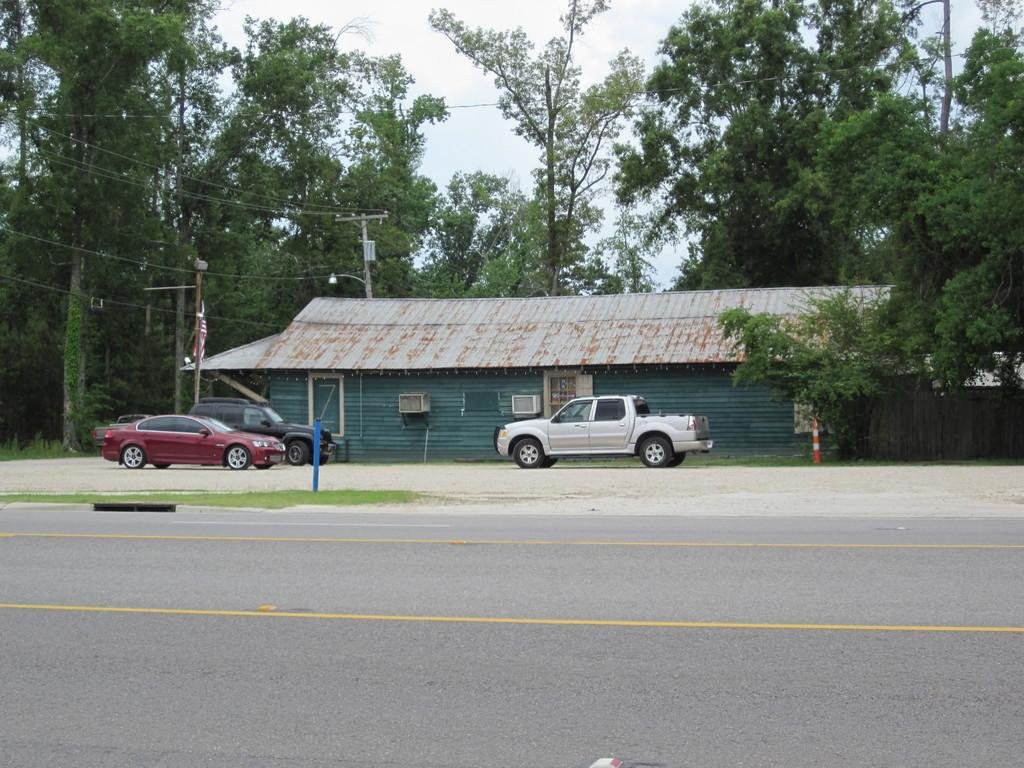What can be seen on the ground in the image? There are vehicles on the ground in the image. What markings are present on the road in the image? There are yellow lines on the road in the image. What is visible in the background of the image? There is a house, trees, poles with wires, and the sky visible in the background of the image. Can you see any blood on the vehicles in the image? There is no blood present on the vehicles in the image. What type of power is being generated by the poles with wires in the image? The image does not provide information about the type of power being generated by the poles with wires. 